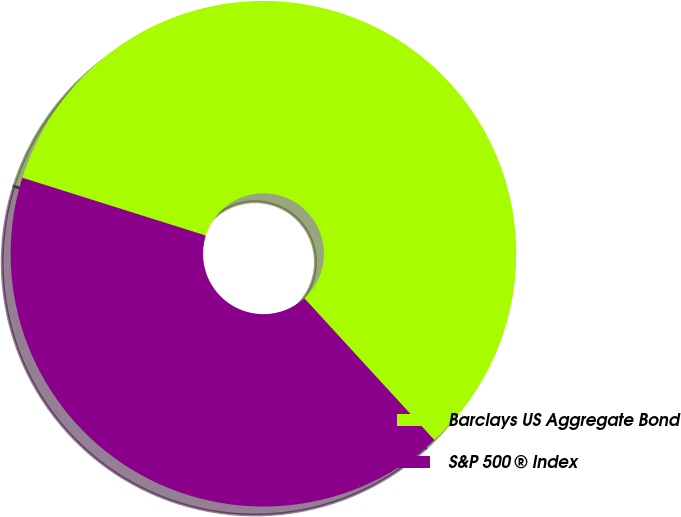Convert chart. <chart><loc_0><loc_0><loc_500><loc_500><pie_chart><fcel>Barclays US Aggregate Bond<fcel>S&P 500 ® Index<nl><fcel>58.33%<fcel>41.67%<nl></chart> 